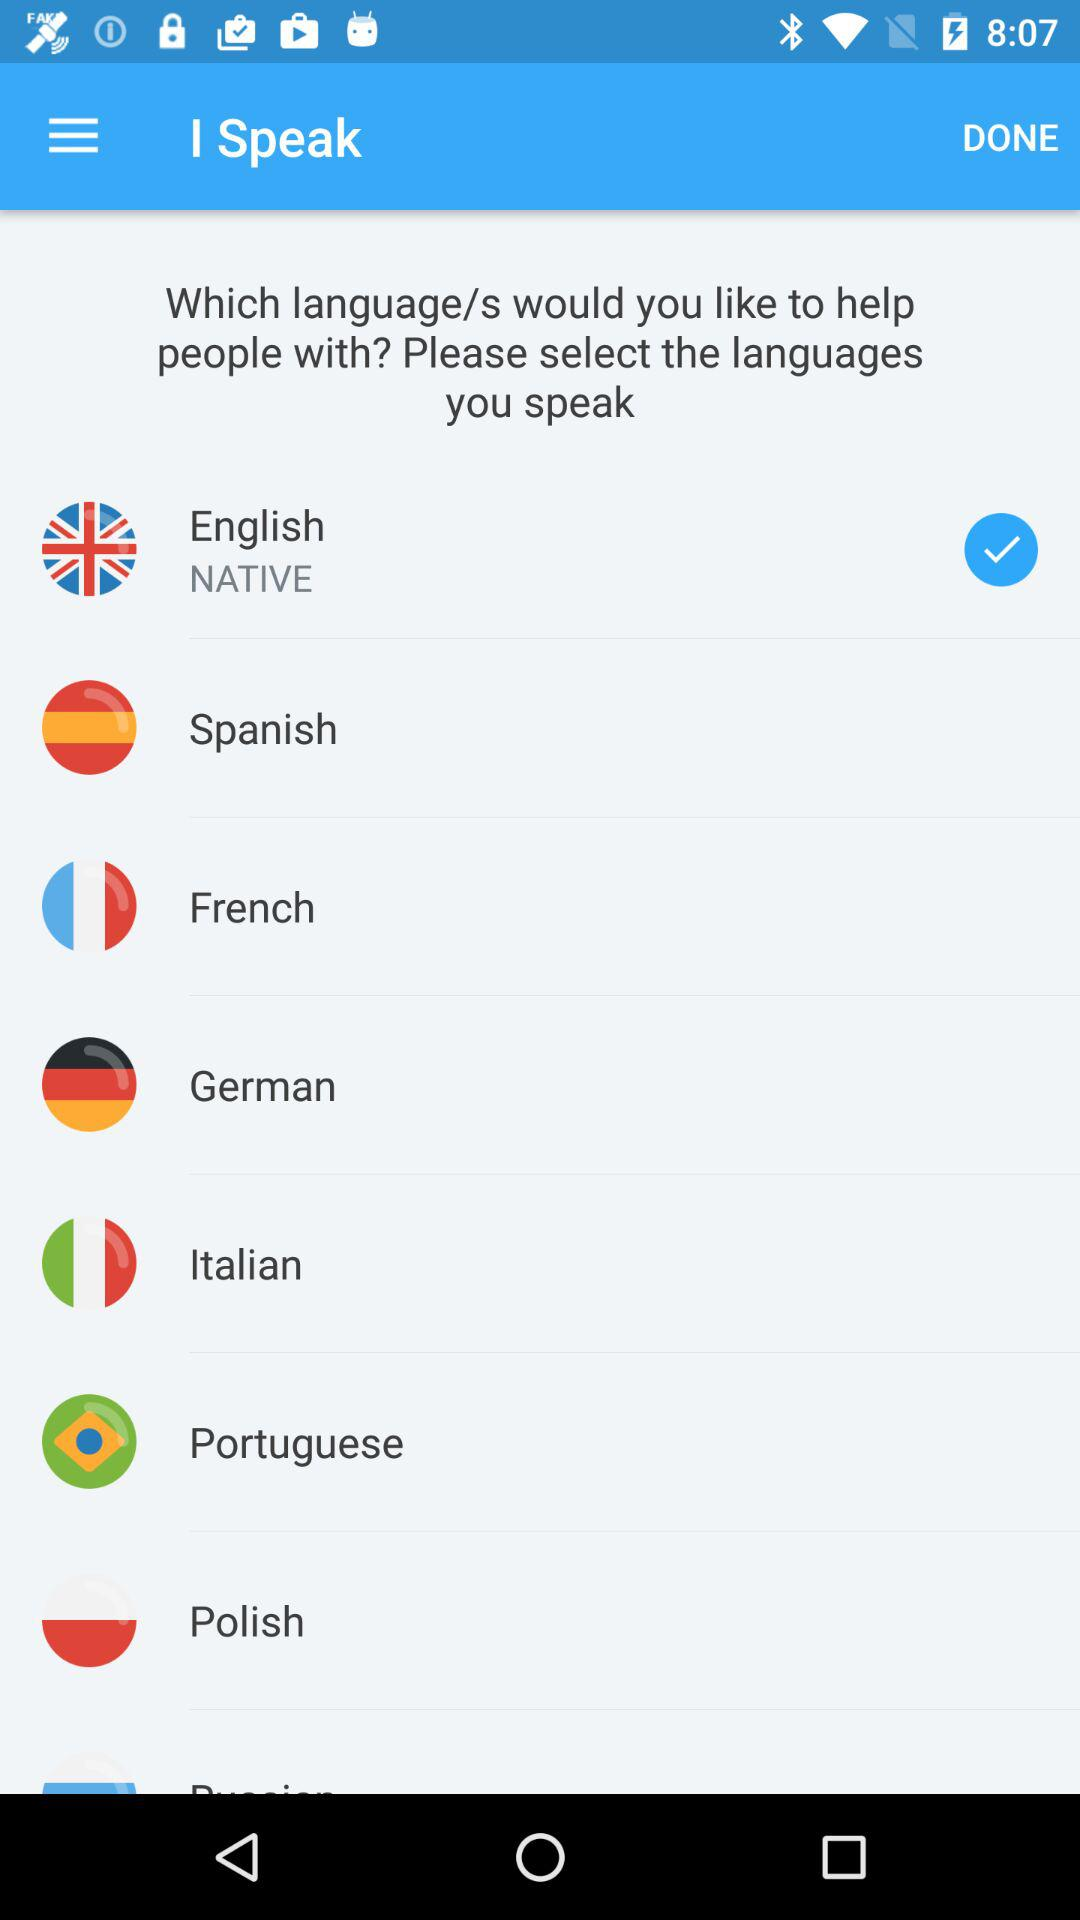What's the native language selected by the user to speak? The native language selected by the user is English. 